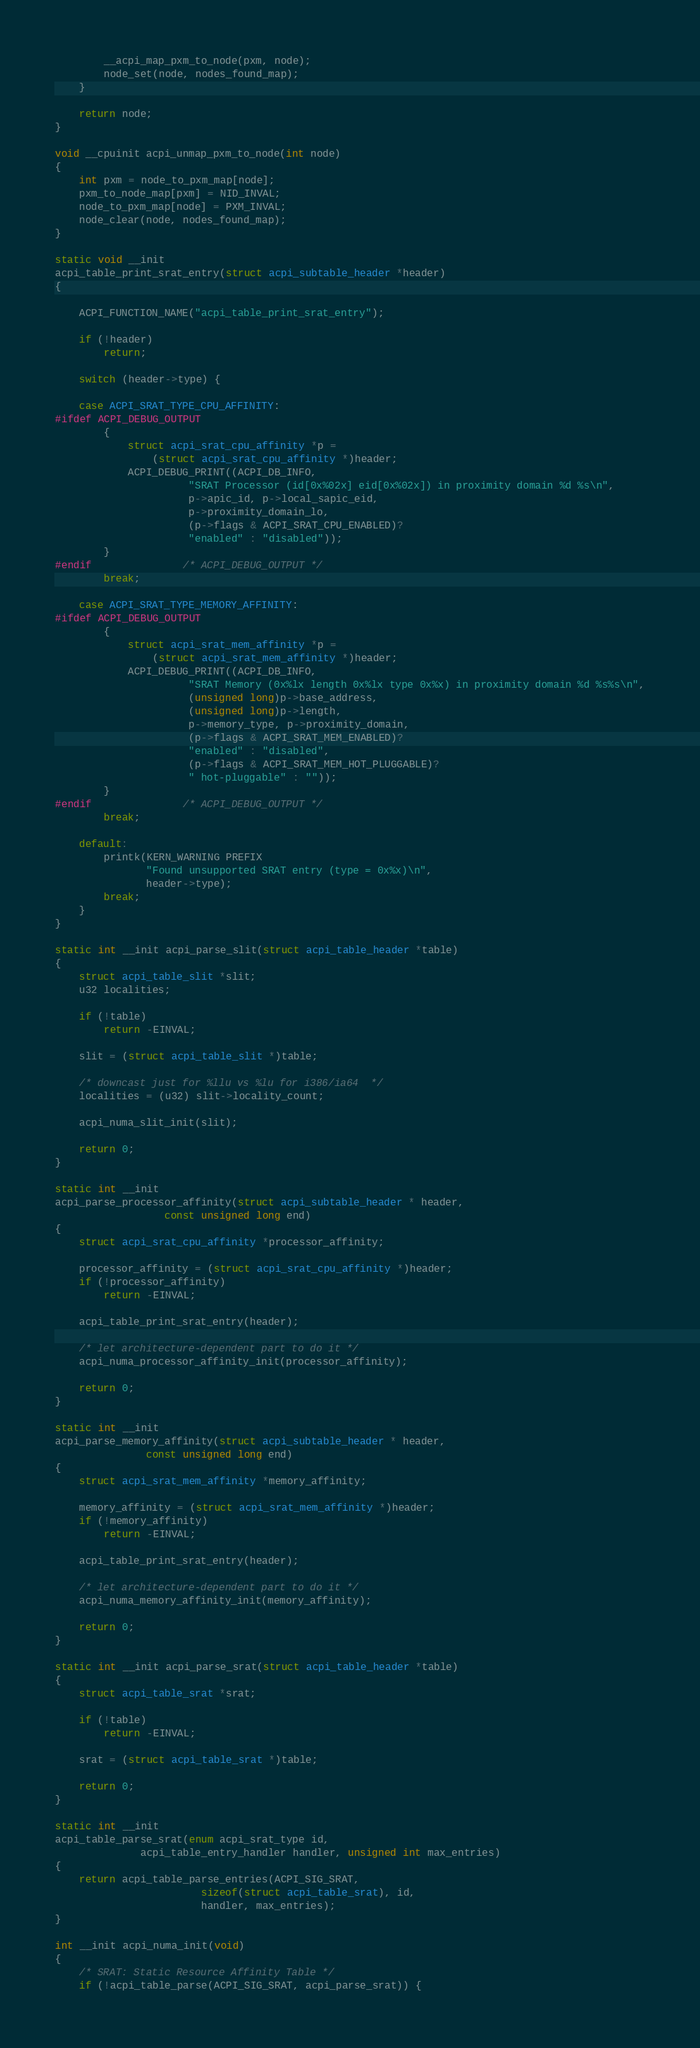Convert code to text. <code><loc_0><loc_0><loc_500><loc_500><_C_>		__acpi_map_pxm_to_node(pxm, node);
		node_set(node, nodes_found_map);
	}

	return node;
}

void __cpuinit acpi_unmap_pxm_to_node(int node)
{
	int pxm = node_to_pxm_map[node];
	pxm_to_node_map[pxm] = NID_INVAL;
	node_to_pxm_map[node] = PXM_INVAL;
	node_clear(node, nodes_found_map);
}

static void __init
acpi_table_print_srat_entry(struct acpi_subtable_header *header)
{

	ACPI_FUNCTION_NAME("acpi_table_print_srat_entry");

	if (!header)
		return;

	switch (header->type) {

	case ACPI_SRAT_TYPE_CPU_AFFINITY:
#ifdef ACPI_DEBUG_OUTPUT
		{
			struct acpi_srat_cpu_affinity *p =
			    (struct acpi_srat_cpu_affinity *)header;
			ACPI_DEBUG_PRINT((ACPI_DB_INFO,
					  "SRAT Processor (id[0x%02x] eid[0x%02x]) in proximity domain %d %s\n",
					  p->apic_id, p->local_sapic_eid,
					  p->proximity_domain_lo,
					  (p->flags & ACPI_SRAT_CPU_ENABLED)?
					  "enabled" : "disabled"));
		}
#endif				/* ACPI_DEBUG_OUTPUT */
		break;

	case ACPI_SRAT_TYPE_MEMORY_AFFINITY:
#ifdef ACPI_DEBUG_OUTPUT
		{
			struct acpi_srat_mem_affinity *p =
			    (struct acpi_srat_mem_affinity *)header;
			ACPI_DEBUG_PRINT((ACPI_DB_INFO,
					  "SRAT Memory (0x%lx length 0x%lx type 0x%x) in proximity domain %d %s%s\n",
					  (unsigned long)p->base_address,
					  (unsigned long)p->length,
					  p->memory_type, p->proximity_domain,
					  (p->flags & ACPI_SRAT_MEM_ENABLED)?
					  "enabled" : "disabled",
					  (p->flags & ACPI_SRAT_MEM_HOT_PLUGGABLE)?
					  " hot-pluggable" : ""));
		}
#endif				/* ACPI_DEBUG_OUTPUT */
		break;

	default:
		printk(KERN_WARNING PREFIX
		       "Found unsupported SRAT entry (type = 0x%x)\n",
		       header->type);
		break;
	}
}

static int __init acpi_parse_slit(struct acpi_table_header *table)
{
	struct acpi_table_slit *slit;
	u32 localities;

	if (!table)
		return -EINVAL;

	slit = (struct acpi_table_slit *)table;

	/* downcast just for %llu vs %lu for i386/ia64  */
	localities = (u32) slit->locality_count;

	acpi_numa_slit_init(slit);

	return 0;
}

static int __init
acpi_parse_processor_affinity(struct acpi_subtable_header * header,
			      const unsigned long end)
{
	struct acpi_srat_cpu_affinity *processor_affinity;

	processor_affinity = (struct acpi_srat_cpu_affinity *)header;
	if (!processor_affinity)
		return -EINVAL;

	acpi_table_print_srat_entry(header);

	/* let architecture-dependent part to do it */
	acpi_numa_processor_affinity_init(processor_affinity);

	return 0;
}

static int __init
acpi_parse_memory_affinity(struct acpi_subtable_header * header,
			   const unsigned long end)
{
	struct acpi_srat_mem_affinity *memory_affinity;

	memory_affinity = (struct acpi_srat_mem_affinity *)header;
	if (!memory_affinity)
		return -EINVAL;

	acpi_table_print_srat_entry(header);

	/* let architecture-dependent part to do it */
	acpi_numa_memory_affinity_init(memory_affinity);

	return 0;
}

static int __init acpi_parse_srat(struct acpi_table_header *table)
{
	struct acpi_table_srat *srat;

	if (!table)
		return -EINVAL;

	srat = (struct acpi_table_srat *)table;

	return 0;
}

static int __init
acpi_table_parse_srat(enum acpi_srat_type id,
		      acpi_table_entry_handler handler, unsigned int max_entries)
{
	return acpi_table_parse_entries(ACPI_SIG_SRAT,
					    sizeof(struct acpi_table_srat), id,
					    handler, max_entries);
}

int __init acpi_numa_init(void)
{
	/* SRAT: Static Resource Affinity Table */
	if (!acpi_table_parse(ACPI_SIG_SRAT, acpi_parse_srat)) {</code> 